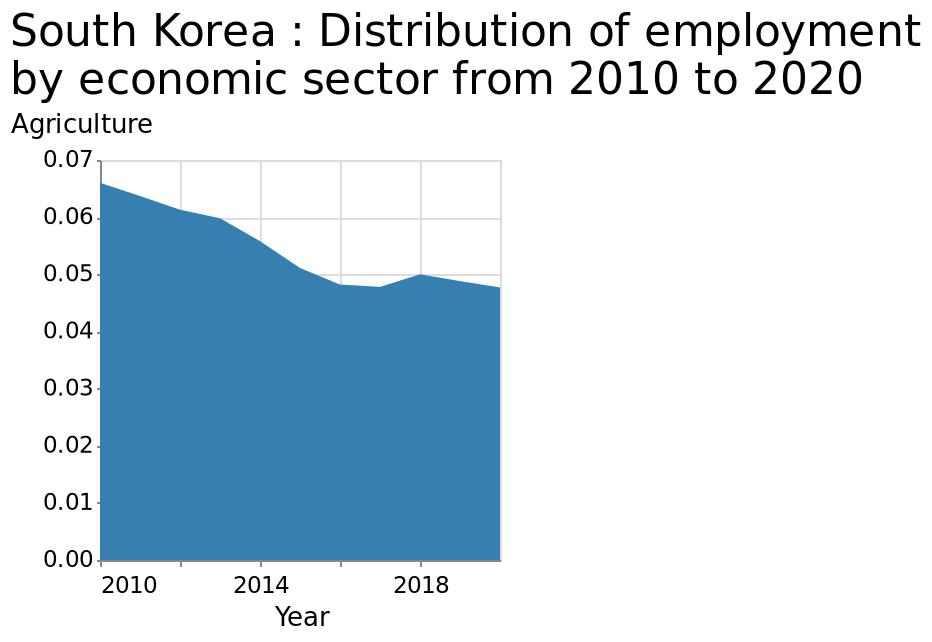<image>
What is the range of the y-axis scale for measuring agriculture? The y-axis scale for measuring agriculture ranges from 0.00 to 0.07. What is the minimum and maximum values on the x-axis? The x-axis has a minimum value of 2010 and a maximum value of 2020. Describe the following image in detail This area graph is named South Korea : Distribution of employment by economic sector from 2010 to 2020. Agriculture is measured using a linear scale of range 0.00 to 0.07 along the y-axis. There is a linear scale with a minimum of 2010 and a maximum of 2018 on the x-axis, labeled Year. How is agriculture measured on the y-axis?  Agriculture is measured using a linear scale of range 0.00 to 0.07 along the y-axis. Did employment in the agriculture sector in South Korea increase in 2018?  Yes, employment in the agriculture sector in South Korea increased to 0.05 in 2018. 